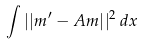<formula> <loc_0><loc_0><loc_500><loc_500>\int | | m ^ { \prime } - A m | | ^ { 2 } \, d x</formula> 